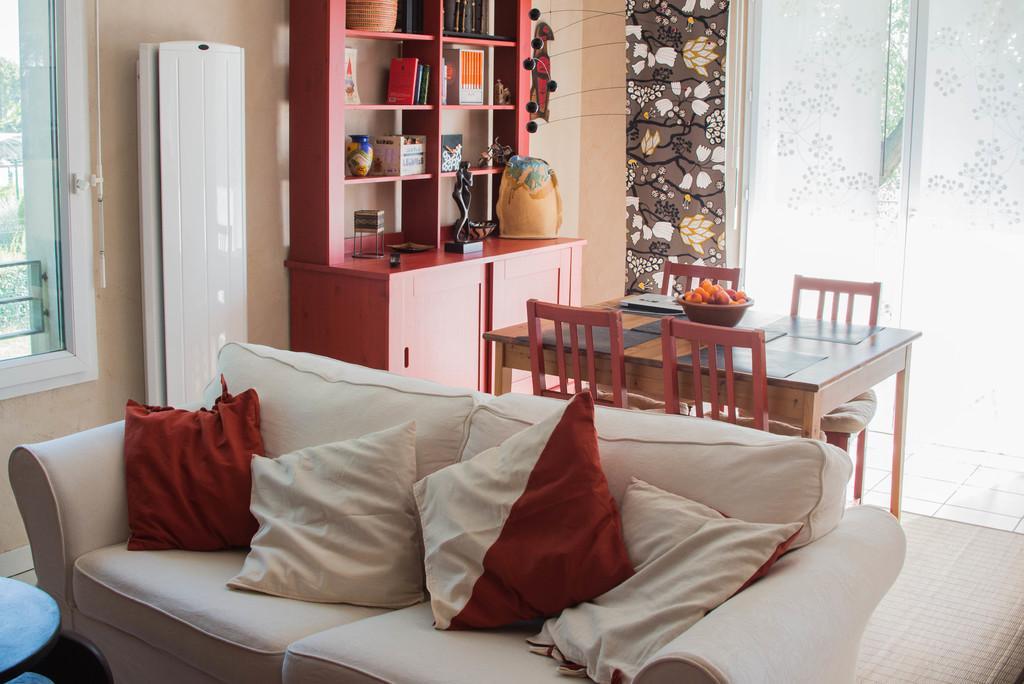Can you describe this image briefly? There is a white sofa which has four pillows on it and there is a dining table and a bookshelf behind it. 